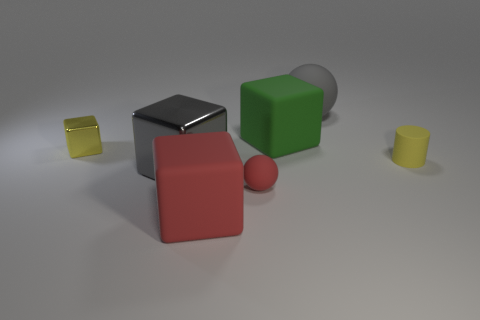Add 2 big gray metallic cubes. How many objects exist? 9 Subtract all blocks. How many objects are left? 3 Subtract 1 yellow cubes. How many objects are left? 6 Subtract all large rubber balls. Subtract all shiny objects. How many objects are left? 4 Add 5 gray metallic objects. How many gray metallic objects are left? 6 Add 3 red matte objects. How many red matte objects exist? 5 